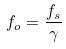<formula> <loc_0><loc_0><loc_500><loc_500>f _ { o } = \frac { f _ { s } } { \gamma }</formula> 